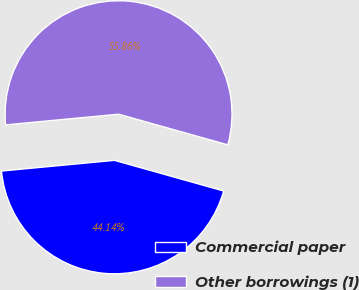<chart> <loc_0><loc_0><loc_500><loc_500><pie_chart><fcel>Commercial paper<fcel>Other borrowings (1)<nl><fcel>44.14%<fcel>55.86%<nl></chart> 